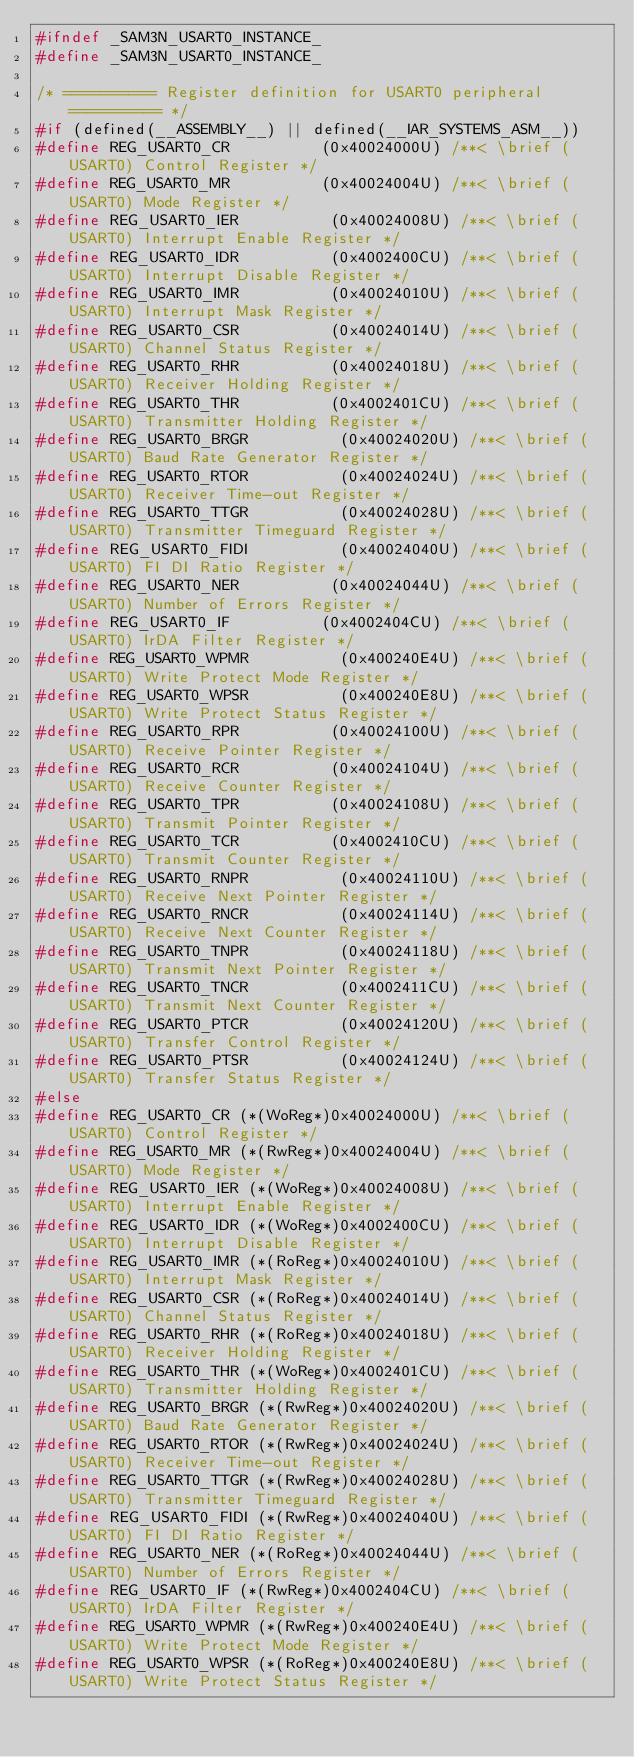<code> <loc_0><loc_0><loc_500><loc_500><_C_>#ifndef _SAM3N_USART0_INSTANCE_
#define _SAM3N_USART0_INSTANCE_

/* ========== Register definition for USART0 peripheral ========== */
#if (defined(__ASSEMBLY__) || defined(__IAR_SYSTEMS_ASM__))
#define REG_USART0_CR          (0x40024000U) /**< \brief (USART0) Control Register */
#define REG_USART0_MR          (0x40024004U) /**< \brief (USART0) Mode Register */
#define REG_USART0_IER          (0x40024008U) /**< \brief (USART0) Interrupt Enable Register */
#define REG_USART0_IDR          (0x4002400CU) /**< \brief (USART0) Interrupt Disable Register */
#define REG_USART0_IMR          (0x40024010U) /**< \brief (USART0) Interrupt Mask Register */
#define REG_USART0_CSR          (0x40024014U) /**< \brief (USART0) Channel Status Register */
#define REG_USART0_RHR          (0x40024018U) /**< \brief (USART0) Receiver Holding Register */
#define REG_USART0_THR          (0x4002401CU) /**< \brief (USART0) Transmitter Holding Register */
#define REG_USART0_BRGR          (0x40024020U) /**< \brief (USART0) Baud Rate Generator Register */
#define REG_USART0_RTOR          (0x40024024U) /**< \brief (USART0) Receiver Time-out Register */
#define REG_USART0_TTGR          (0x40024028U) /**< \brief (USART0) Transmitter Timeguard Register */
#define REG_USART0_FIDI          (0x40024040U) /**< \brief (USART0) FI DI Ratio Register */
#define REG_USART0_NER          (0x40024044U) /**< \brief (USART0) Number of Errors Register */
#define REG_USART0_IF          (0x4002404CU) /**< \brief (USART0) IrDA Filter Register */
#define REG_USART0_WPMR          (0x400240E4U) /**< \brief (USART0) Write Protect Mode Register */
#define REG_USART0_WPSR          (0x400240E8U) /**< \brief (USART0) Write Protect Status Register */
#define REG_USART0_RPR          (0x40024100U) /**< \brief (USART0) Receive Pointer Register */
#define REG_USART0_RCR          (0x40024104U) /**< \brief (USART0) Receive Counter Register */
#define REG_USART0_TPR          (0x40024108U) /**< \brief (USART0) Transmit Pointer Register */
#define REG_USART0_TCR          (0x4002410CU) /**< \brief (USART0) Transmit Counter Register */
#define REG_USART0_RNPR          (0x40024110U) /**< \brief (USART0) Receive Next Pointer Register */
#define REG_USART0_RNCR          (0x40024114U) /**< \brief (USART0) Receive Next Counter Register */
#define REG_USART0_TNPR          (0x40024118U) /**< \brief (USART0) Transmit Next Pointer Register */
#define REG_USART0_TNCR          (0x4002411CU) /**< \brief (USART0) Transmit Next Counter Register */
#define REG_USART0_PTCR          (0x40024120U) /**< \brief (USART0) Transfer Control Register */
#define REG_USART0_PTSR          (0x40024124U) /**< \brief (USART0) Transfer Status Register */
#else
#define REG_USART0_CR (*(WoReg*)0x40024000U) /**< \brief (USART0) Control Register */
#define REG_USART0_MR (*(RwReg*)0x40024004U) /**< \brief (USART0) Mode Register */
#define REG_USART0_IER (*(WoReg*)0x40024008U) /**< \brief (USART0) Interrupt Enable Register */
#define REG_USART0_IDR (*(WoReg*)0x4002400CU) /**< \brief (USART0) Interrupt Disable Register */
#define REG_USART0_IMR (*(RoReg*)0x40024010U) /**< \brief (USART0) Interrupt Mask Register */
#define REG_USART0_CSR (*(RoReg*)0x40024014U) /**< \brief (USART0) Channel Status Register */
#define REG_USART0_RHR (*(RoReg*)0x40024018U) /**< \brief (USART0) Receiver Holding Register */
#define REG_USART0_THR (*(WoReg*)0x4002401CU) /**< \brief (USART0) Transmitter Holding Register */
#define REG_USART0_BRGR (*(RwReg*)0x40024020U) /**< \brief (USART0) Baud Rate Generator Register */
#define REG_USART0_RTOR (*(RwReg*)0x40024024U) /**< \brief (USART0) Receiver Time-out Register */
#define REG_USART0_TTGR (*(RwReg*)0x40024028U) /**< \brief (USART0) Transmitter Timeguard Register */
#define REG_USART0_FIDI (*(RwReg*)0x40024040U) /**< \brief (USART0) FI DI Ratio Register */
#define REG_USART0_NER (*(RoReg*)0x40024044U) /**< \brief (USART0) Number of Errors Register */
#define REG_USART0_IF (*(RwReg*)0x4002404CU) /**< \brief (USART0) IrDA Filter Register */
#define REG_USART0_WPMR (*(RwReg*)0x400240E4U) /**< \brief (USART0) Write Protect Mode Register */
#define REG_USART0_WPSR (*(RoReg*)0x400240E8U) /**< \brief (USART0) Write Protect Status Register */</code> 